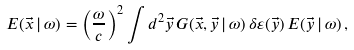Convert formula to latex. <formula><loc_0><loc_0><loc_500><loc_500>E ( \vec { x } \, | \, \omega ) = \left ( \frac { \omega } { c } \right ) ^ { 2 } \int d ^ { 2 } \vec { y } \, G ( \vec { x } , \vec { y } \, | \, \omega ) \, \delta \varepsilon ( \vec { y } ) \, E ( \vec { y } \, | \, \omega ) \, ,</formula> 